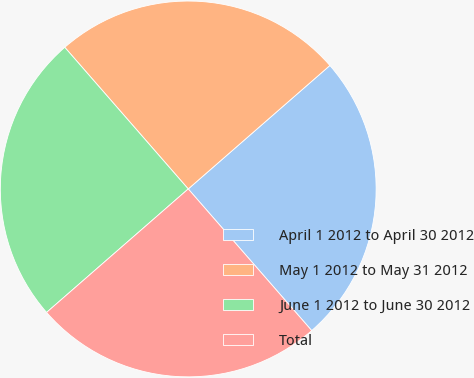Convert chart to OTSL. <chart><loc_0><loc_0><loc_500><loc_500><pie_chart><fcel>April 1 2012 to April 30 2012<fcel>May 1 2012 to May 31 2012<fcel>June 1 2012 to June 30 2012<fcel>Total<nl><fcel>25.0%<fcel>25.0%<fcel>25.0%<fcel>25.0%<nl></chart> 